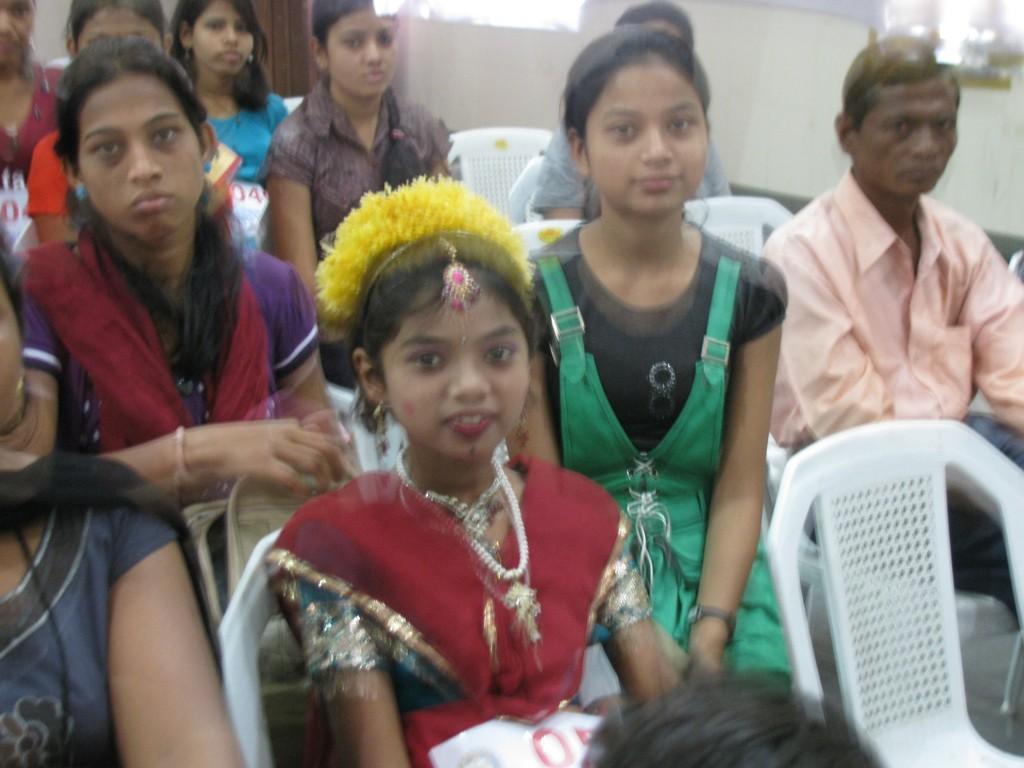In one or two sentences, can you explain what this image depicts? In this image I can see there are few children sitting on chairs and I can see a person sitting on the chair on the right side I can see the wall at the top. 